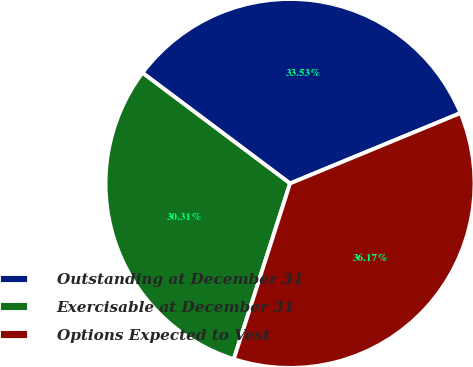Convert chart to OTSL. <chart><loc_0><loc_0><loc_500><loc_500><pie_chart><fcel>Outstanding at December 31<fcel>Exercisable at December 31<fcel>Options Expected to Vest<nl><fcel>33.53%<fcel>30.31%<fcel>36.17%<nl></chart> 